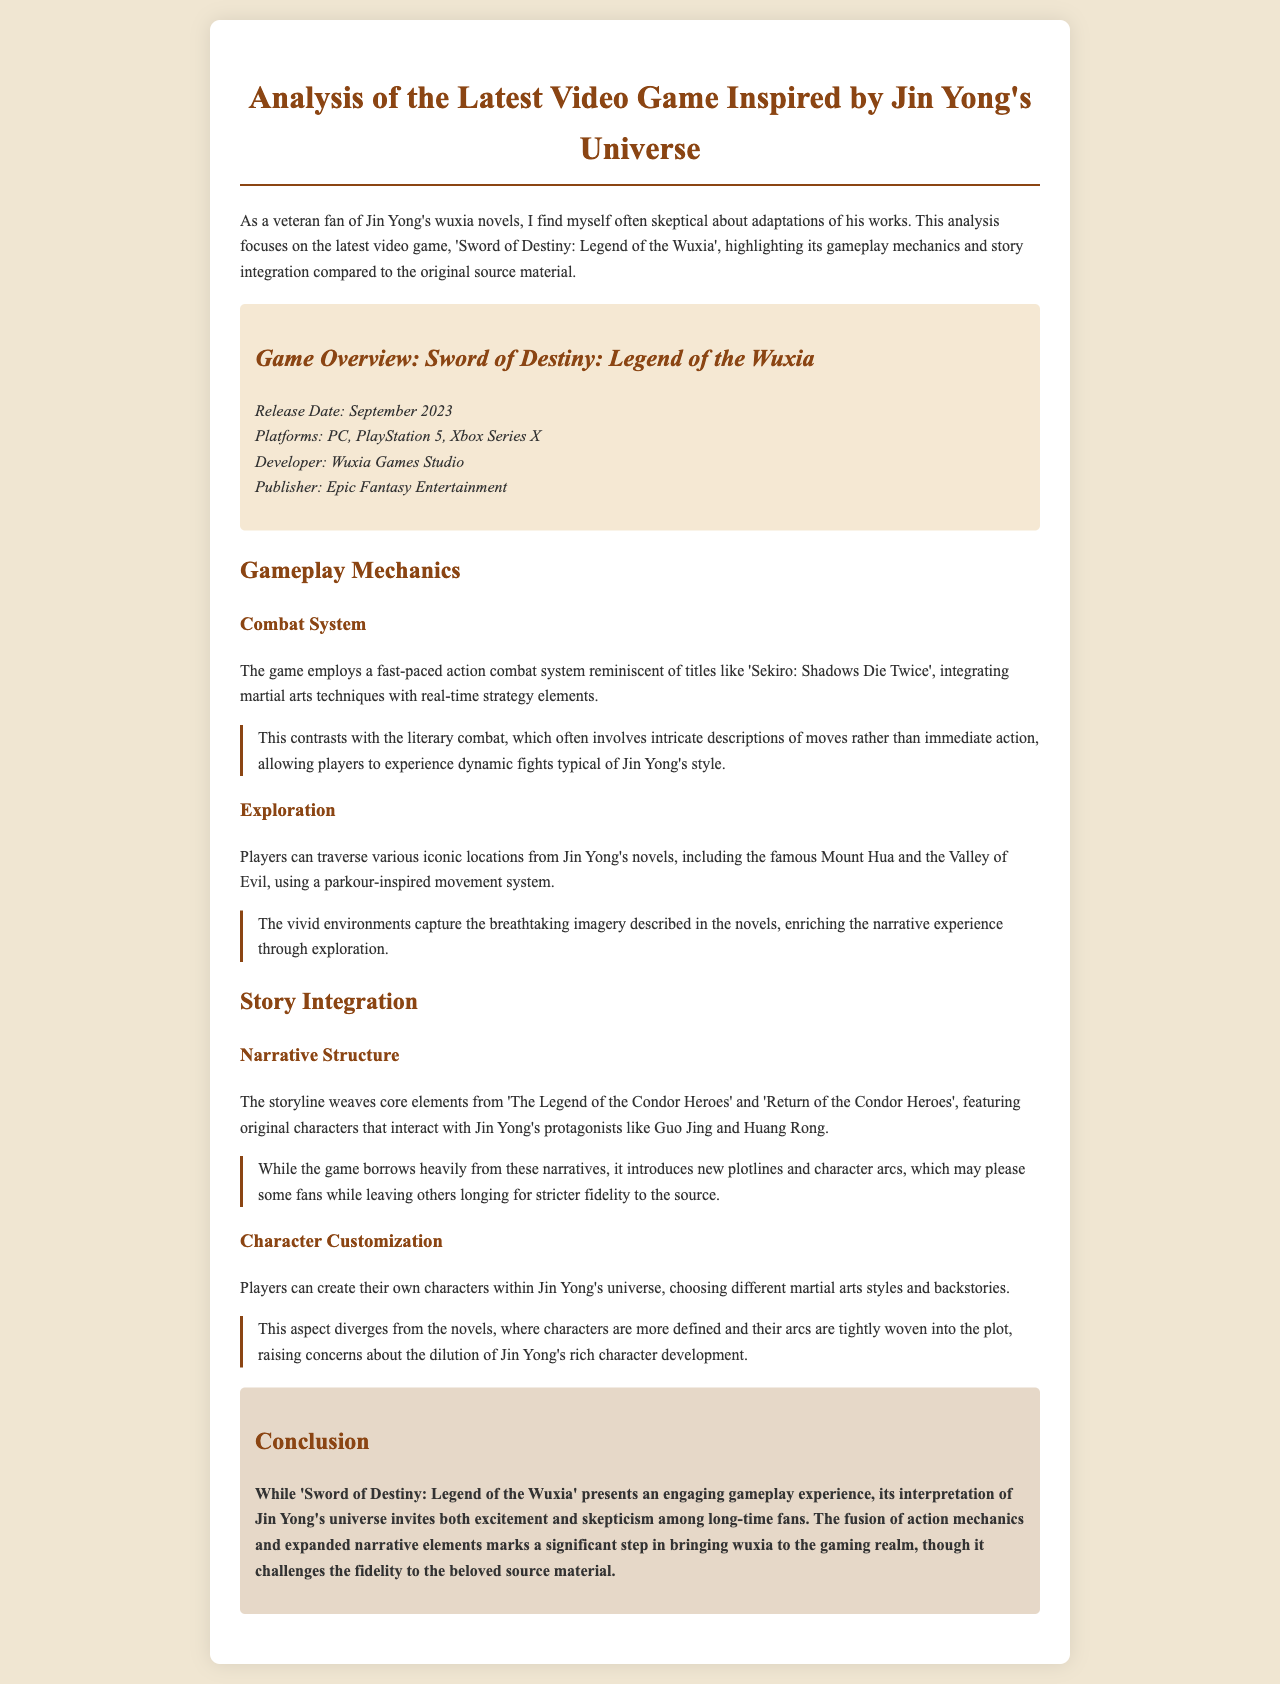What is the release date of the game? The release date is mentioned in the game overview section of the document.
Answer: September 2023 Who developed the game? The document specifies the developer in the game overview section.
Answer: Wuxia Games Studio What is the combat system reminiscent of? The document compares the combat system to another title to highlight its style.
Answer: Sekiro: Shadows Die Twice Which locations can players explore? The document lists specific iconic locations from Jin Yong's novels that players can traverse.
Answer: Mount Hua and the Valley of Evil What core elements does the storyline weave from? The narrative structure section of the document mentions specific titles as sources for the story.
Answer: The Legend of the Condor Heroes and Return of the Condor Heroes What kind of character customization does the game include? The character customization aspect is discussed in detail in the story integration section of the document.
Answer: Different martial arts styles and backstories What is the main concern regarding character customization? The document raises a specific concern about the impact of character customization on the source material.
Answer: Dilution of Jin Yong's rich character development What marks a significant step in bringing wuxia to gaming? The conclusion summarizes what is viewed as a significant advancement in the genre.
Answer: Fusion of action mechanics and expanded narrative elements How does the game affect long-time fans' perceptions? The conclusion reflects on the mixed feelings of the fans regarding the game.
Answer: Excitement and skepticism 